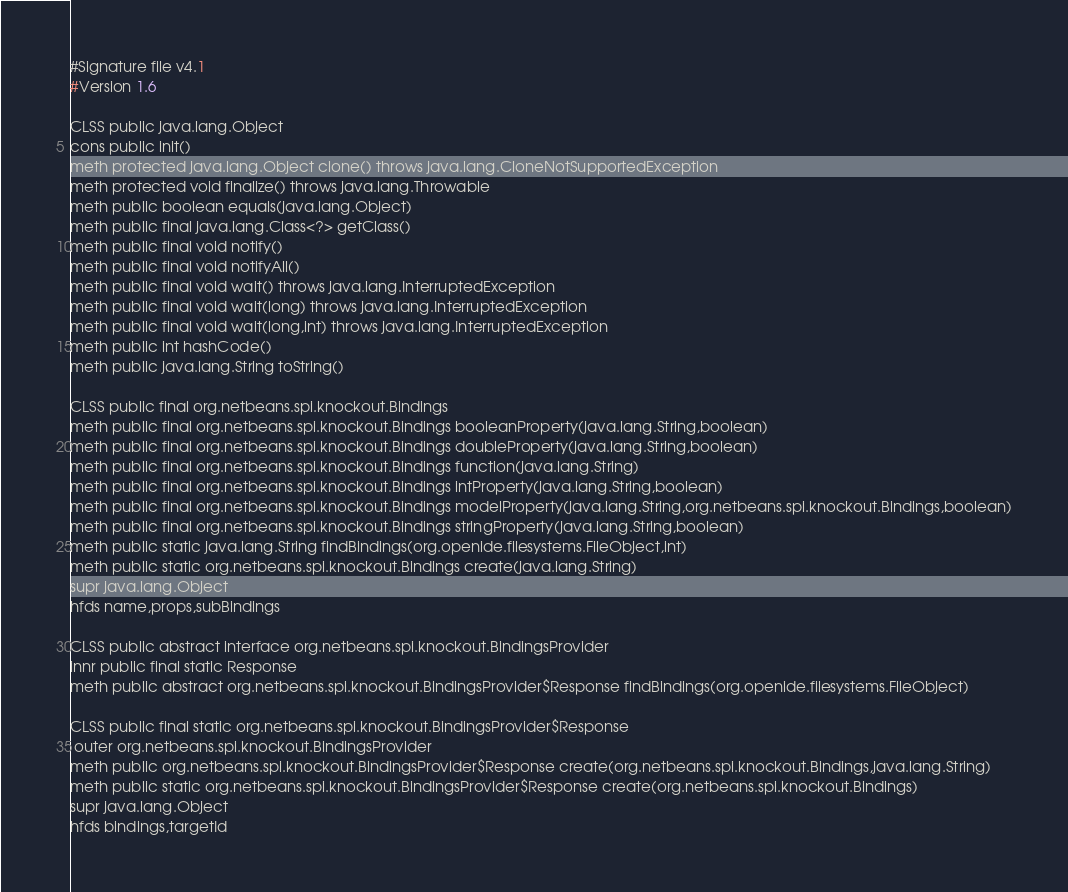<code> <loc_0><loc_0><loc_500><loc_500><_SML_>#Signature file v4.1
#Version 1.6

CLSS public java.lang.Object
cons public init()
meth protected java.lang.Object clone() throws java.lang.CloneNotSupportedException
meth protected void finalize() throws java.lang.Throwable
meth public boolean equals(java.lang.Object)
meth public final java.lang.Class<?> getClass()
meth public final void notify()
meth public final void notifyAll()
meth public final void wait() throws java.lang.InterruptedException
meth public final void wait(long) throws java.lang.InterruptedException
meth public final void wait(long,int) throws java.lang.InterruptedException
meth public int hashCode()
meth public java.lang.String toString()

CLSS public final org.netbeans.spi.knockout.Bindings
meth public final org.netbeans.spi.knockout.Bindings booleanProperty(java.lang.String,boolean)
meth public final org.netbeans.spi.knockout.Bindings doubleProperty(java.lang.String,boolean)
meth public final org.netbeans.spi.knockout.Bindings function(java.lang.String)
meth public final org.netbeans.spi.knockout.Bindings intProperty(java.lang.String,boolean)
meth public final org.netbeans.spi.knockout.Bindings modelProperty(java.lang.String,org.netbeans.spi.knockout.Bindings,boolean)
meth public final org.netbeans.spi.knockout.Bindings stringProperty(java.lang.String,boolean)
meth public static java.lang.String findBindings(org.openide.filesystems.FileObject,int)
meth public static org.netbeans.spi.knockout.Bindings create(java.lang.String)
supr java.lang.Object
hfds name,props,subBindings

CLSS public abstract interface org.netbeans.spi.knockout.BindingsProvider
innr public final static Response
meth public abstract org.netbeans.spi.knockout.BindingsProvider$Response findBindings(org.openide.filesystems.FileObject)

CLSS public final static org.netbeans.spi.knockout.BindingsProvider$Response
 outer org.netbeans.spi.knockout.BindingsProvider
meth public org.netbeans.spi.knockout.BindingsProvider$Response create(org.netbeans.spi.knockout.Bindings,java.lang.String)
meth public static org.netbeans.spi.knockout.BindingsProvider$Response create(org.netbeans.spi.knockout.Bindings)
supr java.lang.Object
hfds bindings,targetId

</code> 